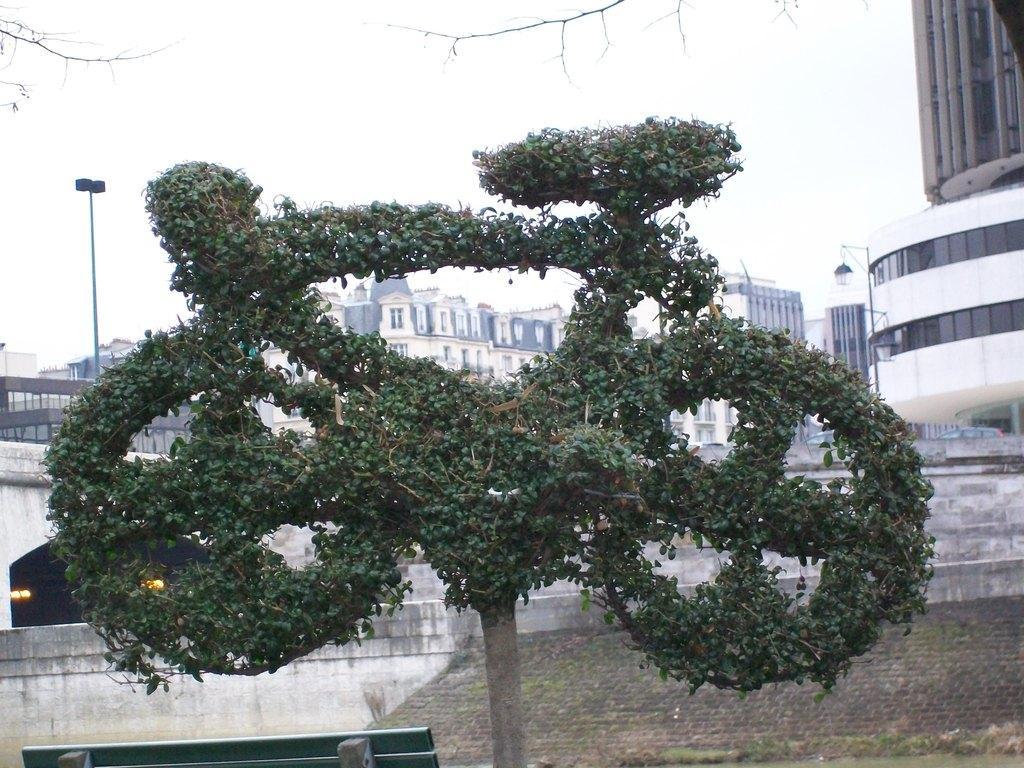Please provide a concise description of this image. In this image we can see a sculpture covered with grass, buildings, poles and sky. 